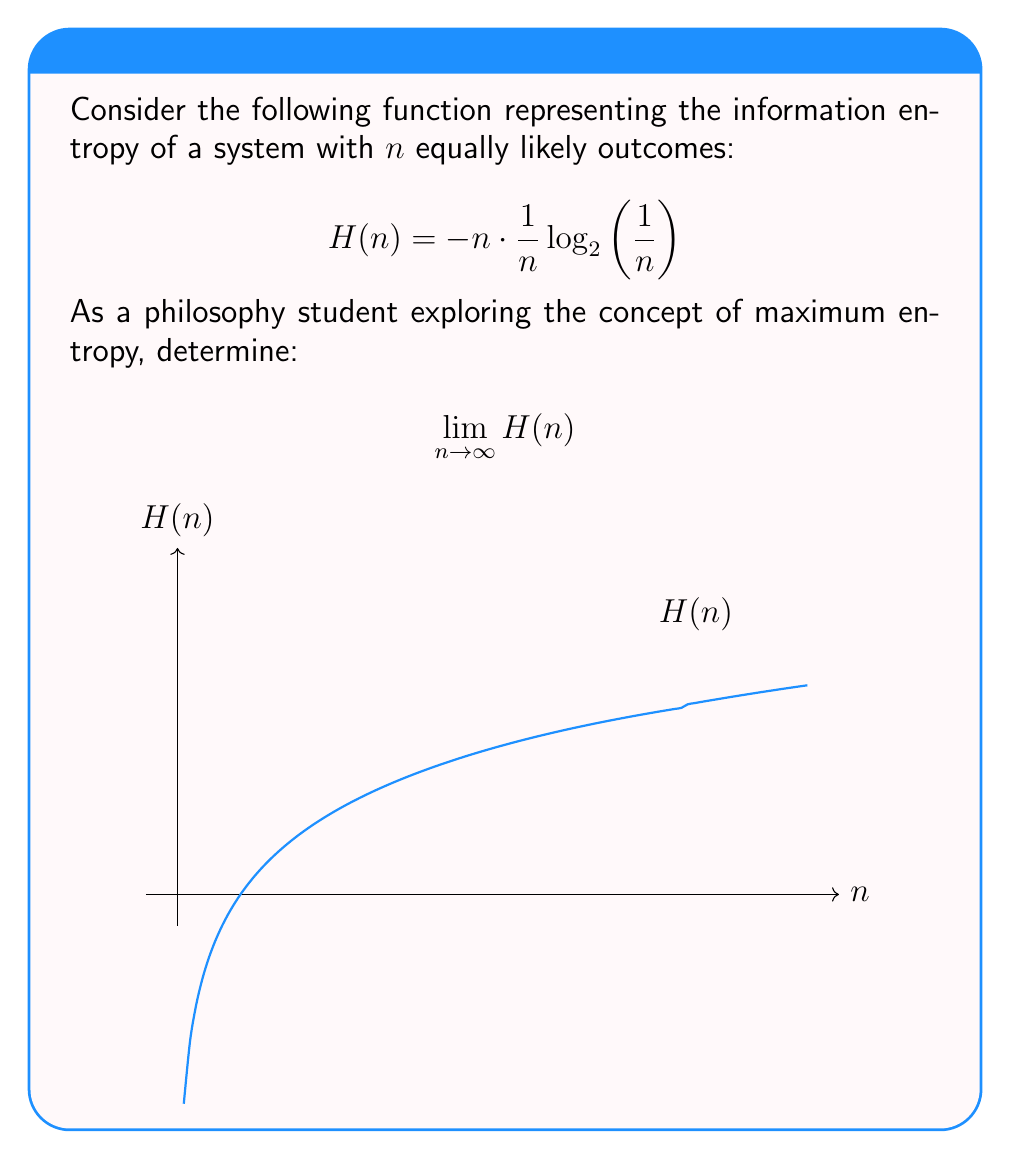Can you answer this question? Let's approach this step-by-step:

1) First, let's simplify the function inside the limit:
   $$H(n) = -n \cdot \frac{1}{n} \log_2\left(\frac{1}{n}\right) = -\log_2\left(\frac{1}{n}\right)$$

2) Now, we can use the change of base formula to convert $\log_2$ to natural log:
   $$H(n) = -\frac{\ln\left(\frac{1}{n}\right)}{\ln(2)}$$

3) Using the properties of logarithms:
   $$H(n) = \frac{\ln(n)}{\ln(2)}$$

4) Now, we need to evaluate:
   $$\lim_{n \to \infty} \frac{\ln(n)}{\ln(2)}$$

5) The numerator $\ln(n)$ approaches infinity as $n$ approaches infinity, while the denominator $\ln(2)$ is constant.

6) Therefore, the limit is:
   $$\lim_{n \to \infty} \frac{\ln(n)}{\ln(2)} = \infty$$

This result aligns with the concept of maximum entropy in information theory, suggesting that as the number of equally likely outcomes in a system approaches infinity, the information entropy of the system also approaches infinity.
Answer: $\infty$ 